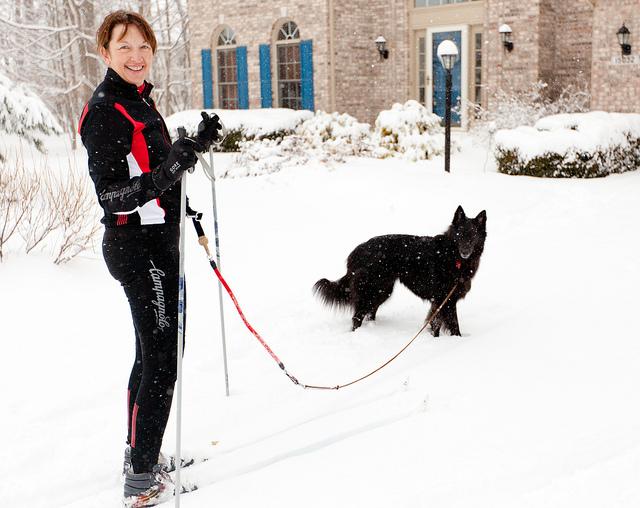What season is it?
Concise answer only. Winter. How many light fixtures do you see?
Quick response, please. 4. Is that a long or short leash?
Short answer required. Long. 